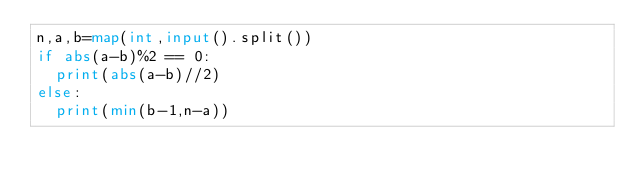Convert code to text. <code><loc_0><loc_0><loc_500><loc_500><_Python_>n,a,b=map(int,input().split())
if abs(a-b)%2 == 0:
  print(abs(a-b)//2)
else:
  print(min(b-1,n-a))
  </code> 